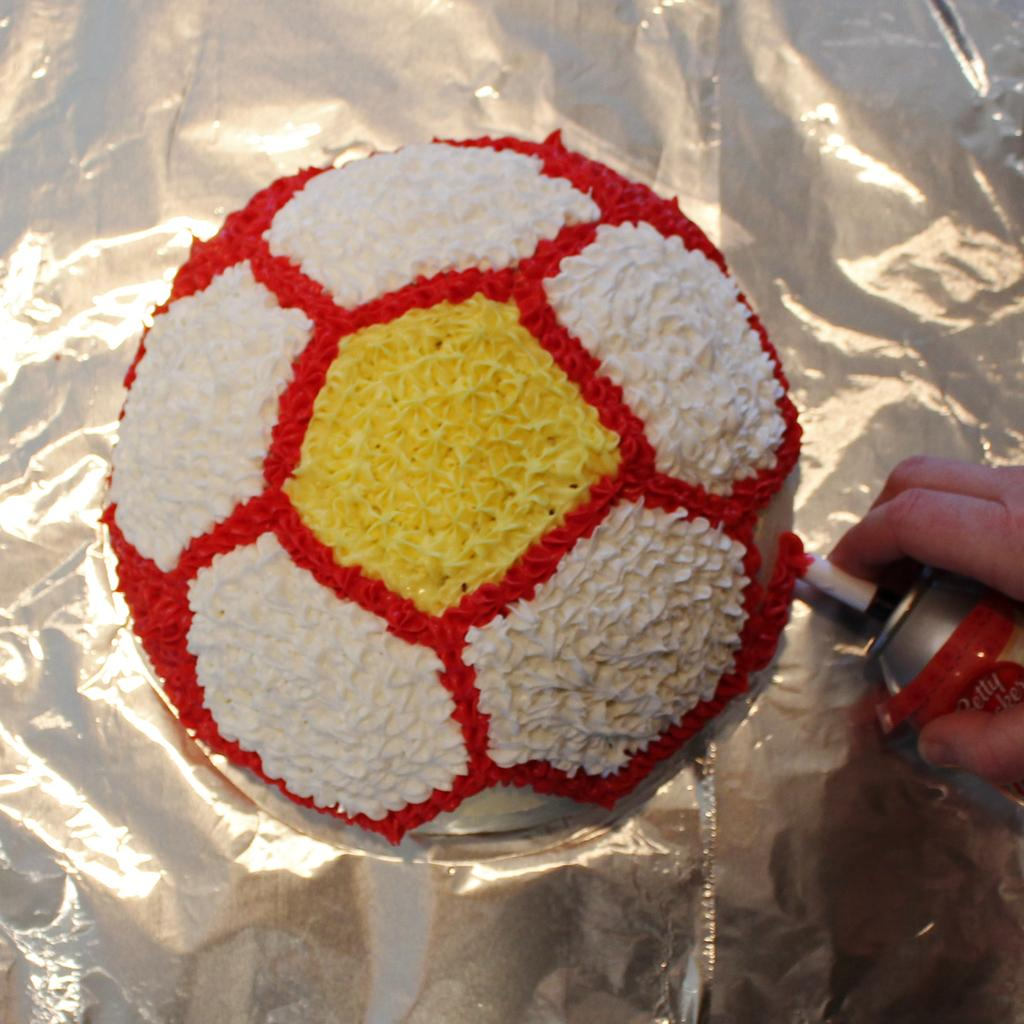What is on the ball in the image? There is cream on a ball in the image. What is the ball placed on? The ball is on silver paper. What object is being held by a person's hand in the image? There is a person's hand holding a spray bottle in the image. On which side of the image is the hand holding the spray bottle? The hand is on the right side of the image. What type of patch is being discussed by the committee in the image? There is no committee or patch present in the image. How does the person's hair look in the image? There is no person's hair visible in the image; only a hand holding a spray bottle is shown. 